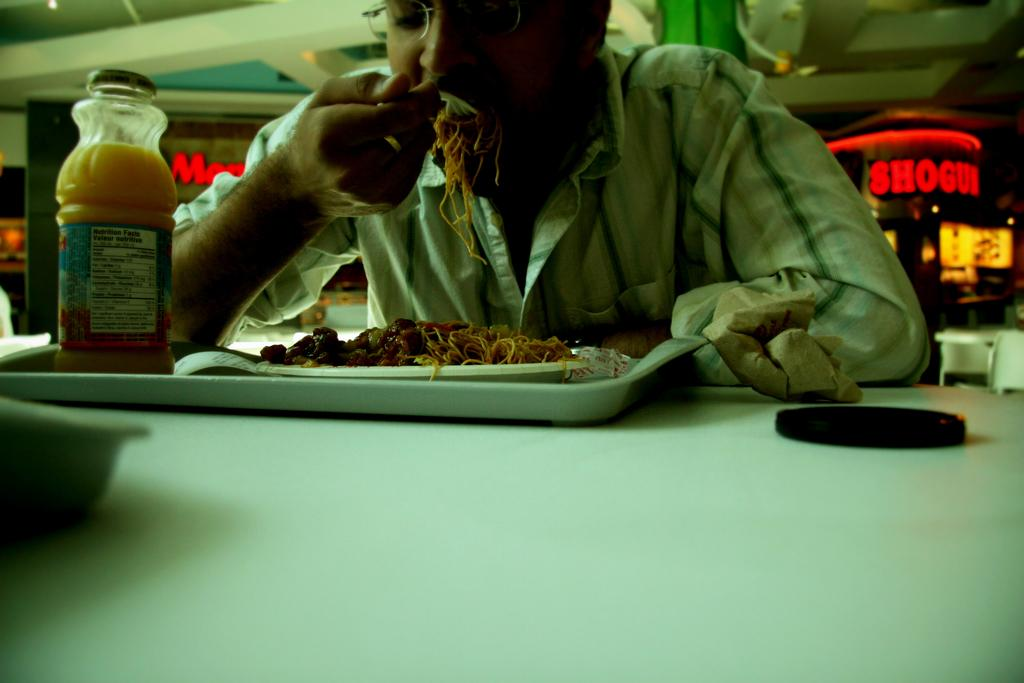<image>
Share a concise interpretation of the image provided. A man eating spaghetti with an oj bottle that has the nutrition facts on the label, in front of a sign for Shogun. 